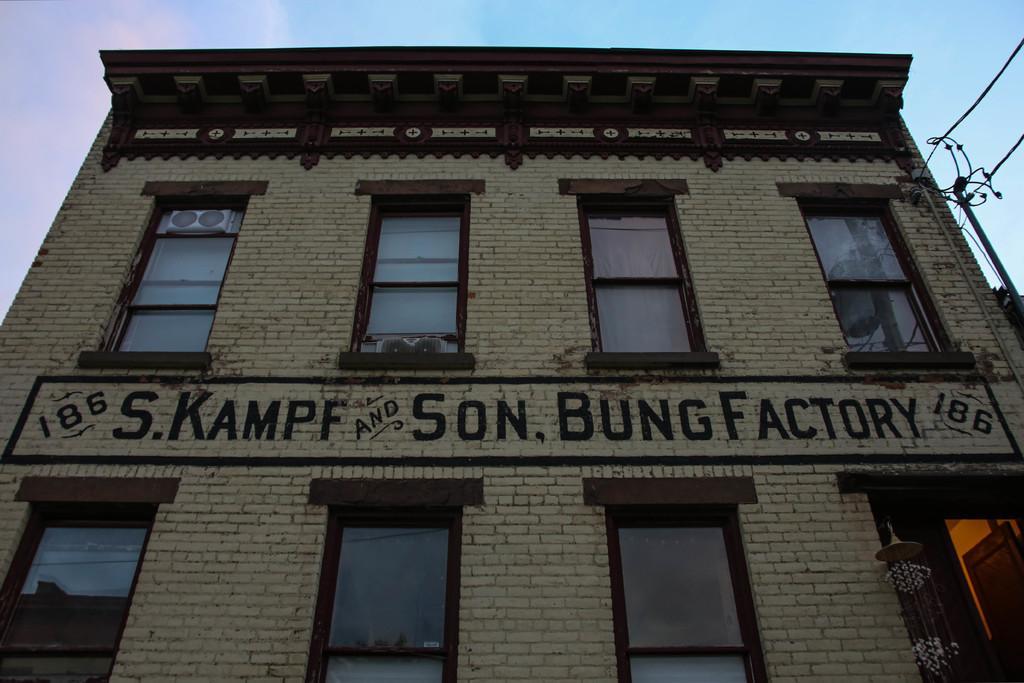Could you give a brief overview of what you see in this image? In the image we can see a building. Behind the building there are some poles and wires and clouds and sky. 